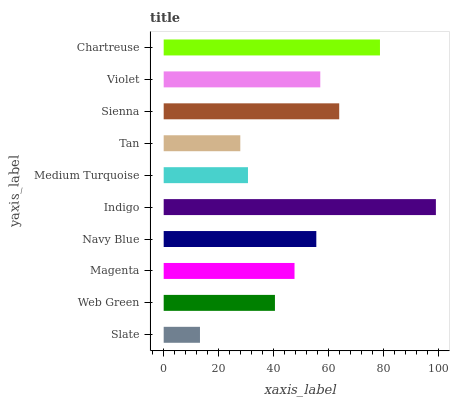Is Slate the minimum?
Answer yes or no. Yes. Is Indigo the maximum?
Answer yes or no. Yes. Is Web Green the minimum?
Answer yes or no. No. Is Web Green the maximum?
Answer yes or no. No. Is Web Green greater than Slate?
Answer yes or no. Yes. Is Slate less than Web Green?
Answer yes or no. Yes. Is Slate greater than Web Green?
Answer yes or no. No. Is Web Green less than Slate?
Answer yes or no. No. Is Navy Blue the high median?
Answer yes or no. Yes. Is Magenta the low median?
Answer yes or no. Yes. Is Slate the high median?
Answer yes or no. No. Is Slate the low median?
Answer yes or no. No. 